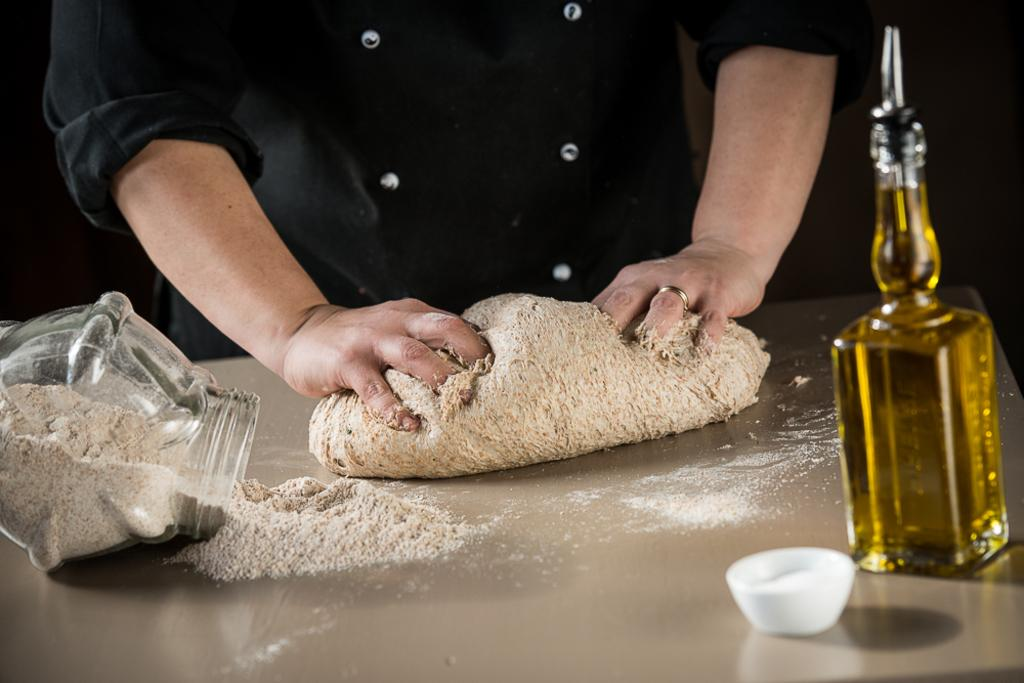What is the person in the image doing? The person is mixing flour with their hands. What can be seen beside the person in the image? There is an oil bottle beside the person. What is located on the right side of the image? There is a flour jar on the right side of the image. Can you see the person's toes in the image? There is no indication of the person's toes being visible in the image. 